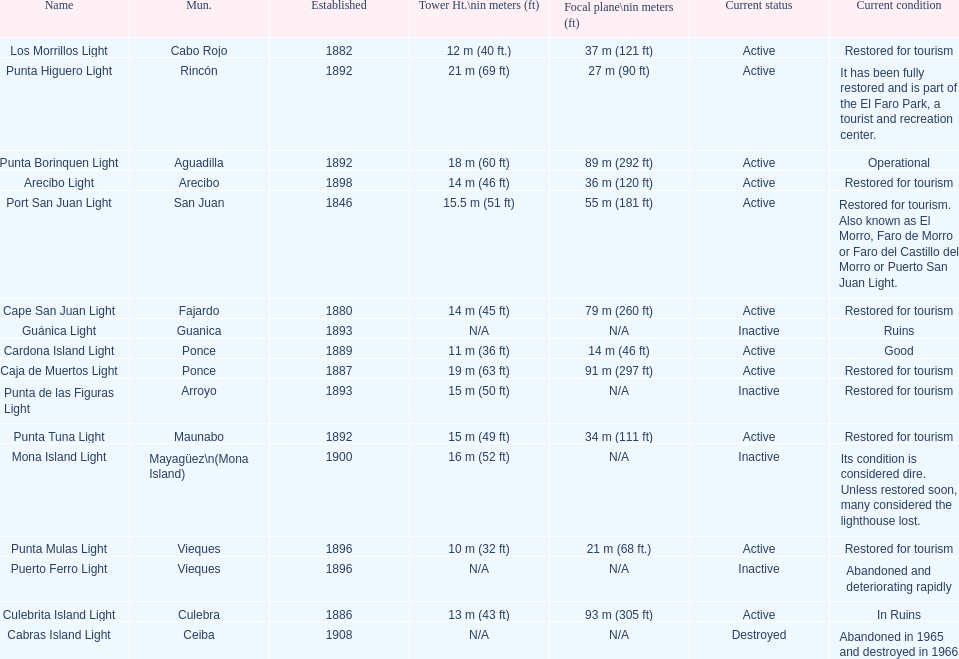The difference in years from 1882 to 1889 7. 